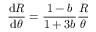Convert formula to latex. <formula><loc_0><loc_0><loc_500><loc_500>\frac { d R } { d \theta } = \frac { 1 - b } { 1 + 3 b } \frac { R } { \theta }</formula> 